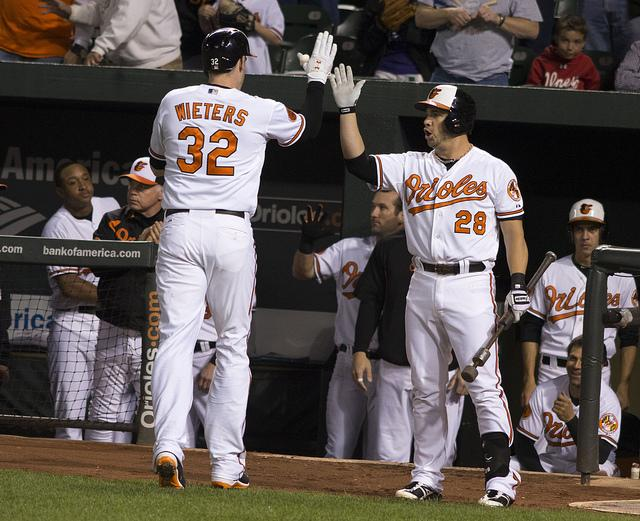What are the players here likely celebrating?

Choices:
A) break time
B) raise
C) homerun
D) bonus homerun 